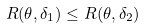<formula> <loc_0><loc_0><loc_500><loc_500>R ( \theta , \delta _ { 1 } ) \leq R ( \theta , \delta _ { 2 } )</formula> 